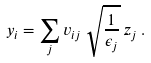<formula> <loc_0><loc_0><loc_500><loc_500>y _ { i } = \sum _ { j } v _ { i j } \, { \sqrt { \frac { 1 } { \epsilon _ { j } } } } \, z _ { j } \, .</formula> 